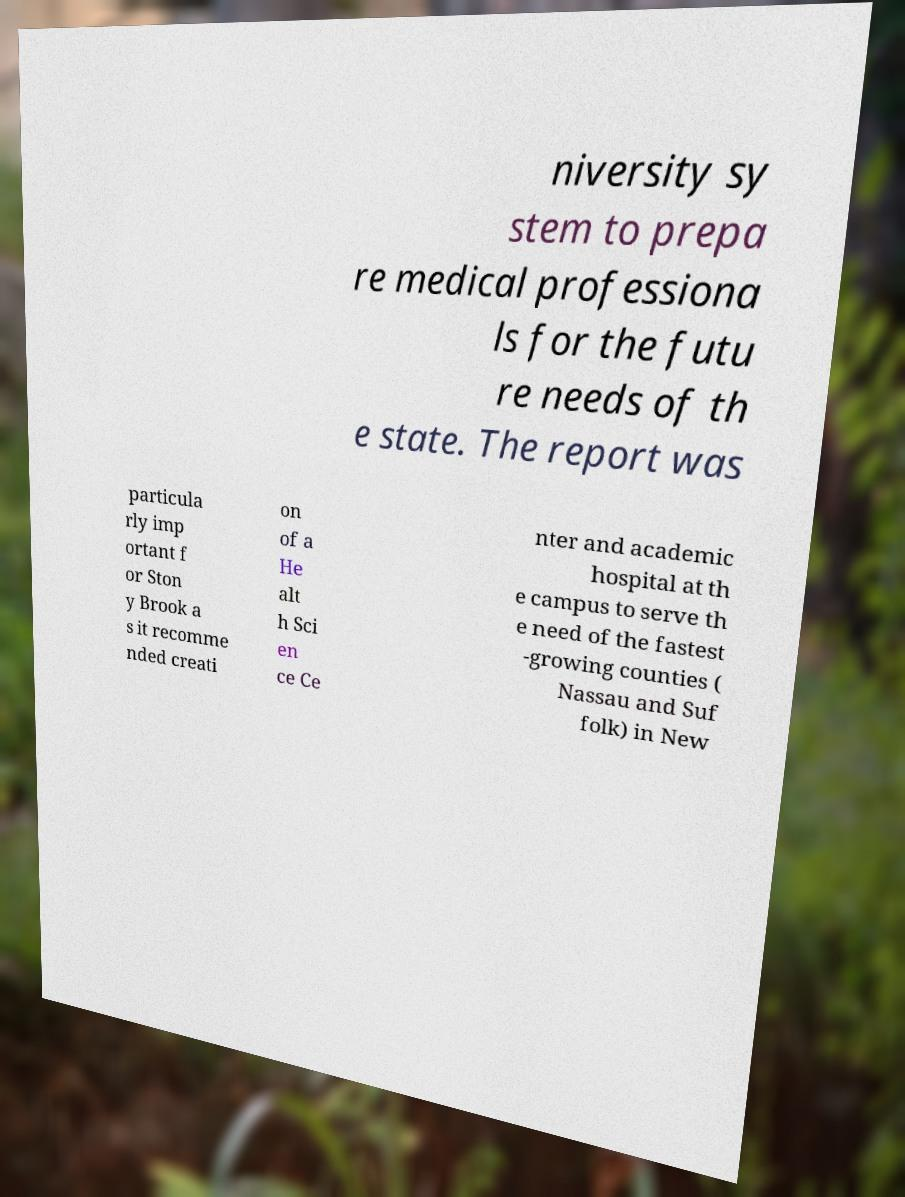For documentation purposes, I need the text within this image transcribed. Could you provide that? niversity sy stem to prepa re medical professiona ls for the futu re needs of th e state. The report was particula rly imp ortant f or Ston y Brook a s it recomme nded creati on of a He alt h Sci en ce Ce nter and academic hospital at th e campus to serve th e need of the fastest -growing counties ( Nassau and Suf folk) in New 